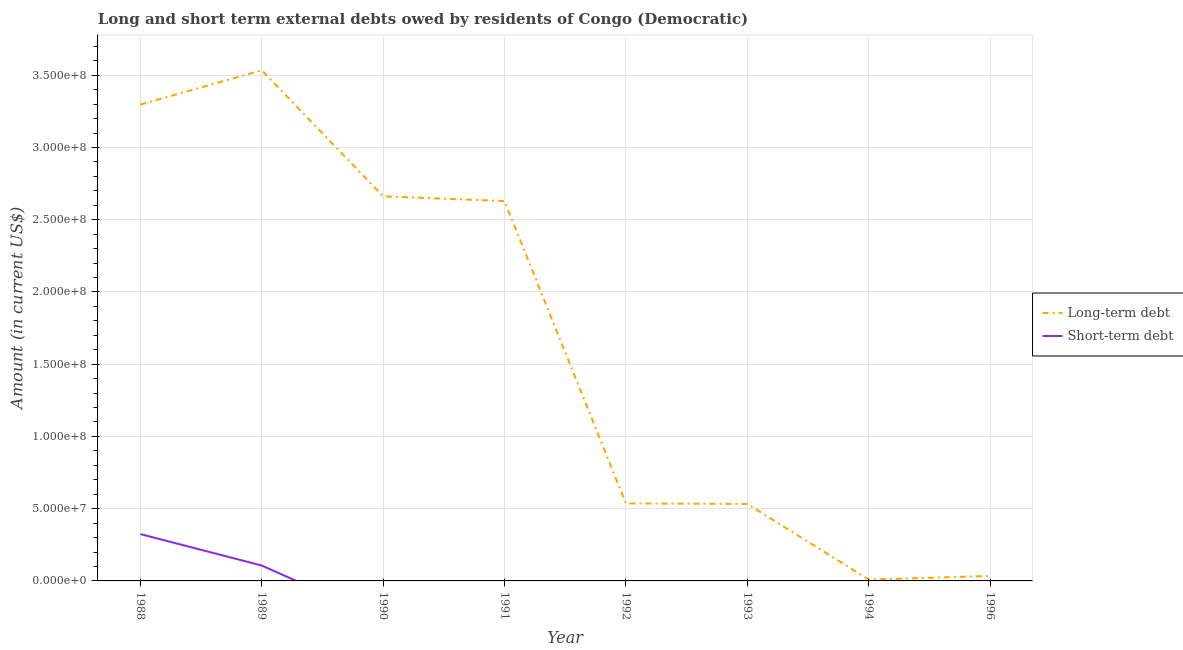What is the short-term debts owed by residents in 1990?
Offer a terse response. 0. Across all years, what is the maximum long-term debts owed by residents?
Keep it short and to the point. 3.53e+08. Across all years, what is the minimum long-term debts owed by residents?
Your answer should be very brief. 9.35e+05. In which year was the long-term debts owed by residents maximum?
Provide a short and direct response. 1989. What is the total long-term debts owed by residents in the graph?
Keep it short and to the point. 1.32e+09. What is the difference between the long-term debts owed by residents in 1992 and that in 1993?
Your answer should be very brief. 3.46e+05. What is the difference between the long-term debts owed by residents in 1994 and the short-term debts owed by residents in 1992?
Provide a short and direct response. 9.35e+05. What is the average short-term debts owed by residents per year?
Keep it short and to the point. 5.38e+06. In the year 1988, what is the difference between the short-term debts owed by residents and long-term debts owed by residents?
Make the answer very short. -2.97e+08. In how many years, is the short-term debts owed by residents greater than 80000000 US$?
Your response must be concise. 0. What is the ratio of the long-term debts owed by residents in 1989 to that in 1993?
Keep it short and to the point. 6.63. What is the difference between the highest and the second highest long-term debts owed by residents?
Your response must be concise. 2.37e+07. What is the difference between the highest and the lowest short-term debts owed by residents?
Ensure brevity in your answer.  3.24e+07. In how many years, is the short-term debts owed by residents greater than the average short-term debts owed by residents taken over all years?
Provide a succinct answer. 2. How many lines are there?
Your response must be concise. 2. Are the values on the major ticks of Y-axis written in scientific E-notation?
Make the answer very short. Yes. Does the graph contain any zero values?
Provide a succinct answer. Yes. Where does the legend appear in the graph?
Ensure brevity in your answer.  Center right. How many legend labels are there?
Give a very brief answer. 2. How are the legend labels stacked?
Offer a very short reply. Vertical. What is the title of the graph?
Ensure brevity in your answer.  Long and short term external debts owed by residents of Congo (Democratic). Does "Arms imports" appear as one of the legend labels in the graph?
Your answer should be very brief. No. What is the label or title of the Y-axis?
Offer a very short reply. Amount (in current US$). What is the Amount (in current US$) in Long-term debt in 1988?
Your answer should be compact. 3.30e+08. What is the Amount (in current US$) of Short-term debt in 1988?
Offer a very short reply. 3.24e+07. What is the Amount (in current US$) of Long-term debt in 1989?
Provide a short and direct response. 3.53e+08. What is the Amount (in current US$) in Short-term debt in 1989?
Keep it short and to the point. 1.06e+07. What is the Amount (in current US$) in Long-term debt in 1990?
Ensure brevity in your answer.  2.66e+08. What is the Amount (in current US$) in Long-term debt in 1991?
Make the answer very short. 2.63e+08. What is the Amount (in current US$) of Long-term debt in 1992?
Provide a succinct answer. 5.36e+07. What is the Amount (in current US$) of Short-term debt in 1992?
Your answer should be compact. 0. What is the Amount (in current US$) of Long-term debt in 1993?
Give a very brief answer. 5.33e+07. What is the Amount (in current US$) in Long-term debt in 1994?
Ensure brevity in your answer.  9.35e+05. What is the Amount (in current US$) of Short-term debt in 1994?
Your answer should be compact. 0. What is the Amount (in current US$) of Long-term debt in 1996?
Offer a terse response. 3.42e+06. Across all years, what is the maximum Amount (in current US$) in Long-term debt?
Ensure brevity in your answer.  3.53e+08. Across all years, what is the maximum Amount (in current US$) in Short-term debt?
Provide a succinct answer. 3.24e+07. Across all years, what is the minimum Amount (in current US$) of Long-term debt?
Provide a short and direct response. 9.35e+05. What is the total Amount (in current US$) in Long-term debt in the graph?
Your answer should be very brief. 1.32e+09. What is the total Amount (in current US$) of Short-term debt in the graph?
Keep it short and to the point. 4.31e+07. What is the difference between the Amount (in current US$) of Long-term debt in 1988 and that in 1989?
Keep it short and to the point. -2.37e+07. What is the difference between the Amount (in current US$) of Short-term debt in 1988 and that in 1989?
Give a very brief answer. 2.18e+07. What is the difference between the Amount (in current US$) of Long-term debt in 1988 and that in 1990?
Keep it short and to the point. 6.35e+07. What is the difference between the Amount (in current US$) of Long-term debt in 1988 and that in 1991?
Offer a very short reply. 6.68e+07. What is the difference between the Amount (in current US$) of Long-term debt in 1988 and that in 1992?
Keep it short and to the point. 2.76e+08. What is the difference between the Amount (in current US$) of Long-term debt in 1988 and that in 1993?
Keep it short and to the point. 2.76e+08. What is the difference between the Amount (in current US$) in Long-term debt in 1988 and that in 1994?
Keep it short and to the point. 3.29e+08. What is the difference between the Amount (in current US$) of Long-term debt in 1988 and that in 1996?
Your answer should be very brief. 3.26e+08. What is the difference between the Amount (in current US$) of Long-term debt in 1989 and that in 1990?
Provide a short and direct response. 8.72e+07. What is the difference between the Amount (in current US$) in Long-term debt in 1989 and that in 1991?
Your answer should be compact. 9.05e+07. What is the difference between the Amount (in current US$) in Long-term debt in 1989 and that in 1992?
Your answer should be compact. 3.00e+08. What is the difference between the Amount (in current US$) in Long-term debt in 1989 and that in 1993?
Keep it short and to the point. 3.00e+08. What is the difference between the Amount (in current US$) of Long-term debt in 1989 and that in 1994?
Keep it short and to the point. 3.53e+08. What is the difference between the Amount (in current US$) of Long-term debt in 1989 and that in 1996?
Keep it short and to the point. 3.50e+08. What is the difference between the Amount (in current US$) in Long-term debt in 1990 and that in 1991?
Offer a very short reply. 3.32e+06. What is the difference between the Amount (in current US$) in Long-term debt in 1990 and that in 1992?
Your answer should be very brief. 2.13e+08. What is the difference between the Amount (in current US$) in Long-term debt in 1990 and that in 1993?
Keep it short and to the point. 2.13e+08. What is the difference between the Amount (in current US$) of Long-term debt in 1990 and that in 1994?
Your answer should be very brief. 2.65e+08. What is the difference between the Amount (in current US$) of Long-term debt in 1990 and that in 1996?
Your answer should be very brief. 2.63e+08. What is the difference between the Amount (in current US$) in Long-term debt in 1991 and that in 1992?
Your answer should be compact. 2.09e+08. What is the difference between the Amount (in current US$) of Long-term debt in 1991 and that in 1993?
Ensure brevity in your answer.  2.10e+08. What is the difference between the Amount (in current US$) of Long-term debt in 1991 and that in 1994?
Your response must be concise. 2.62e+08. What is the difference between the Amount (in current US$) in Long-term debt in 1991 and that in 1996?
Provide a short and direct response. 2.59e+08. What is the difference between the Amount (in current US$) of Long-term debt in 1992 and that in 1993?
Your response must be concise. 3.46e+05. What is the difference between the Amount (in current US$) in Long-term debt in 1992 and that in 1994?
Provide a short and direct response. 5.27e+07. What is the difference between the Amount (in current US$) of Long-term debt in 1992 and that in 1996?
Provide a succinct answer. 5.02e+07. What is the difference between the Amount (in current US$) in Long-term debt in 1993 and that in 1994?
Offer a terse response. 5.23e+07. What is the difference between the Amount (in current US$) of Long-term debt in 1993 and that in 1996?
Ensure brevity in your answer.  4.99e+07. What is the difference between the Amount (in current US$) in Long-term debt in 1994 and that in 1996?
Provide a short and direct response. -2.49e+06. What is the difference between the Amount (in current US$) of Long-term debt in 1988 and the Amount (in current US$) of Short-term debt in 1989?
Offer a very short reply. 3.19e+08. What is the average Amount (in current US$) of Long-term debt per year?
Make the answer very short. 1.65e+08. What is the average Amount (in current US$) of Short-term debt per year?
Provide a short and direct response. 5.38e+06. In the year 1988, what is the difference between the Amount (in current US$) of Long-term debt and Amount (in current US$) of Short-term debt?
Provide a short and direct response. 2.97e+08. In the year 1989, what is the difference between the Amount (in current US$) in Long-term debt and Amount (in current US$) in Short-term debt?
Your answer should be compact. 3.43e+08. What is the ratio of the Amount (in current US$) of Long-term debt in 1988 to that in 1989?
Ensure brevity in your answer.  0.93. What is the ratio of the Amount (in current US$) of Short-term debt in 1988 to that in 1989?
Offer a terse response. 3.04. What is the ratio of the Amount (in current US$) in Long-term debt in 1988 to that in 1990?
Provide a succinct answer. 1.24. What is the ratio of the Amount (in current US$) of Long-term debt in 1988 to that in 1991?
Your answer should be compact. 1.25. What is the ratio of the Amount (in current US$) in Long-term debt in 1988 to that in 1992?
Your answer should be very brief. 6.15. What is the ratio of the Amount (in current US$) in Long-term debt in 1988 to that in 1993?
Make the answer very short. 6.19. What is the ratio of the Amount (in current US$) in Long-term debt in 1988 to that in 1994?
Ensure brevity in your answer.  352.63. What is the ratio of the Amount (in current US$) in Long-term debt in 1988 to that in 1996?
Make the answer very short. 96.27. What is the ratio of the Amount (in current US$) in Long-term debt in 1989 to that in 1990?
Make the answer very short. 1.33. What is the ratio of the Amount (in current US$) in Long-term debt in 1989 to that in 1991?
Your response must be concise. 1.34. What is the ratio of the Amount (in current US$) of Long-term debt in 1989 to that in 1992?
Provide a succinct answer. 6.59. What is the ratio of the Amount (in current US$) of Long-term debt in 1989 to that in 1993?
Give a very brief answer. 6.63. What is the ratio of the Amount (in current US$) in Long-term debt in 1989 to that in 1994?
Provide a succinct answer. 378.01. What is the ratio of the Amount (in current US$) of Long-term debt in 1989 to that in 1996?
Provide a short and direct response. 103.19. What is the ratio of the Amount (in current US$) in Long-term debt in 1990 to that in 1991?
Offer a very short reply. 1.01. What is the ratio of the Amount (in current US$) of Long-term debt in 1990 to that in 1992?
Offer a very short reply. 4.96. What is the ratio of the Amount (in current US$) in Long-term debt in 1990 to that in 1993?
Provide a short and direct response. 5. What is the ratio of the Amount (in current US$) of Long-term debt in 1990 to that in 1994?
Ensure brevity in your answer.  284.73. What is the ratio of the Amount (in current US$) in Long-term debt in 1990 to that in 1996?
Make the answer very short. 77.73. What is the ratio of the Amount (in current US$) of Long-term debt in 1991 to that in 1992?
Keep it short and to the point. 4.9. What is the ratio of the Amount (in current US$) of Long-term debt in 1991 to that in 1993?
Make the answer very short. 4.93. What is the ratio of the Amount (in current US$) of Long-term debt in 1991 to that in 1994?
Give a very brief answer. 281.17. What is the ratio of the Amount (in current US$) of Long-term debt in 1991 to that in 1996?
Your answer should be very brief. 76.76. What is the ratio of the Amount (in current US$) of Long-term debt in 1992 to that in 1993?
Make the answer very short. 1.01. What is the ratio of the Amount (in current US$) of Long-term debt in 1992 to that in 1994?
Offer a very short reply. 57.35. What is the ratio of the Amount (in current US$) in Long-term debt in 1992 to that in 1996?
Your response must be concise. 15.66. What is the ratio of the Amount (in current US$) of Long-term debt in 1993 to that in 1994?
Ensure brevity in your answer.  56.98. What is the ratio of the Amount (in current US$) in Long-term debt in 1993 to that in 1996?
Your answer should be compact. 15.56. What is the ratio of the Amount (in current US$) of Long-term debt in 1994 to that in 1996?
Give a very brief answer. 0.27. What is the difference between the highest and the second highest Amount (in current US$) of Long-term debt?
Keep it short and to the point. 2.37e+07. What is the difference between the highest and the lowest Amount (in current US$) of Long-term debt?
Your response must be concise. 3.53e+08. What is the difference between the highest and the lowest Amount (in current US$) in Short-term debt?
Give a very brief answer. 3.24e+07. 